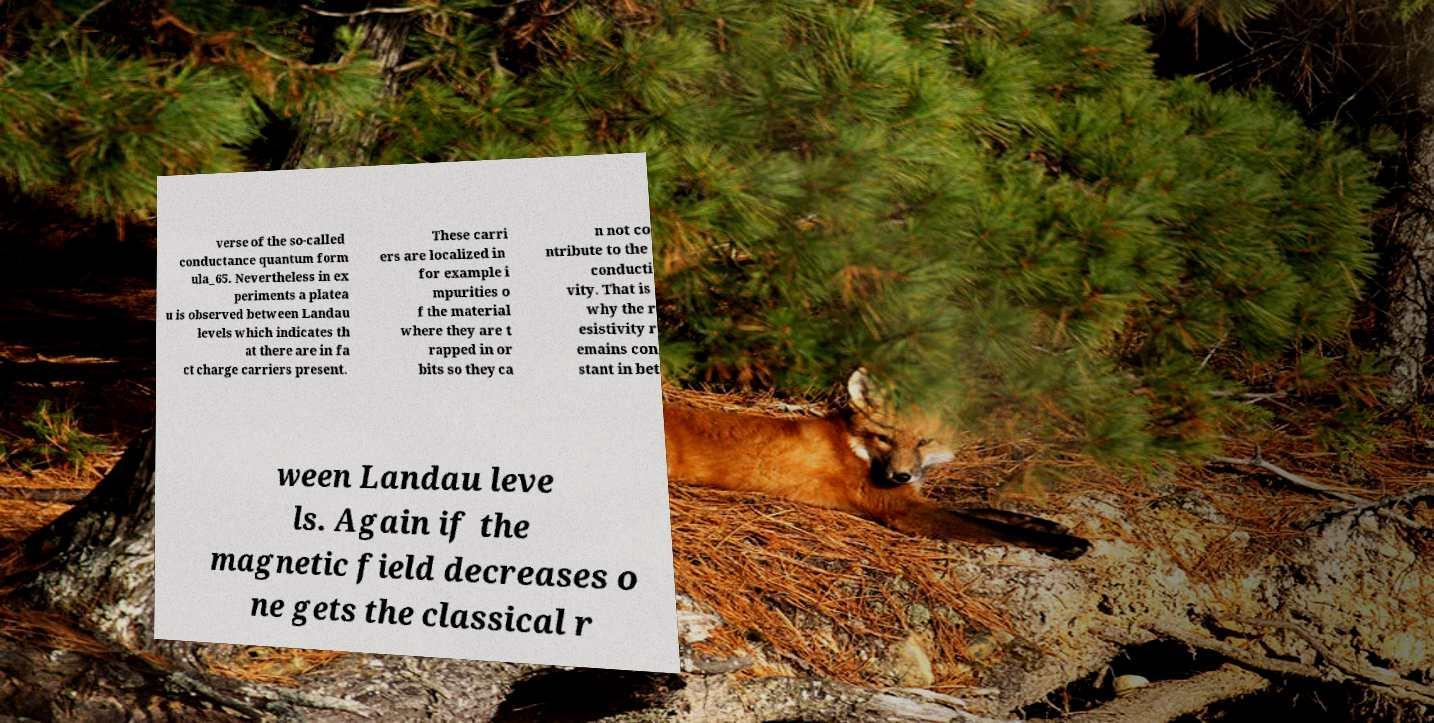I need the written content from this picture converted into text. Can you do that? verse of the so-called conductance quantum form ula_65. Nevertheless in ex periments a platea u is observed between Landau levels which indicates th at there are in fa ct charge carriers present. These carri ers are localized in for example i mpurities o f the material where they are t rapped in or bits so they ca n not co ntribute to the conducti vity. That is why the r esistivity r emains con stant in bet ween Landau leve ls. Again if the magnetic field decreases o ne gets the classical r 